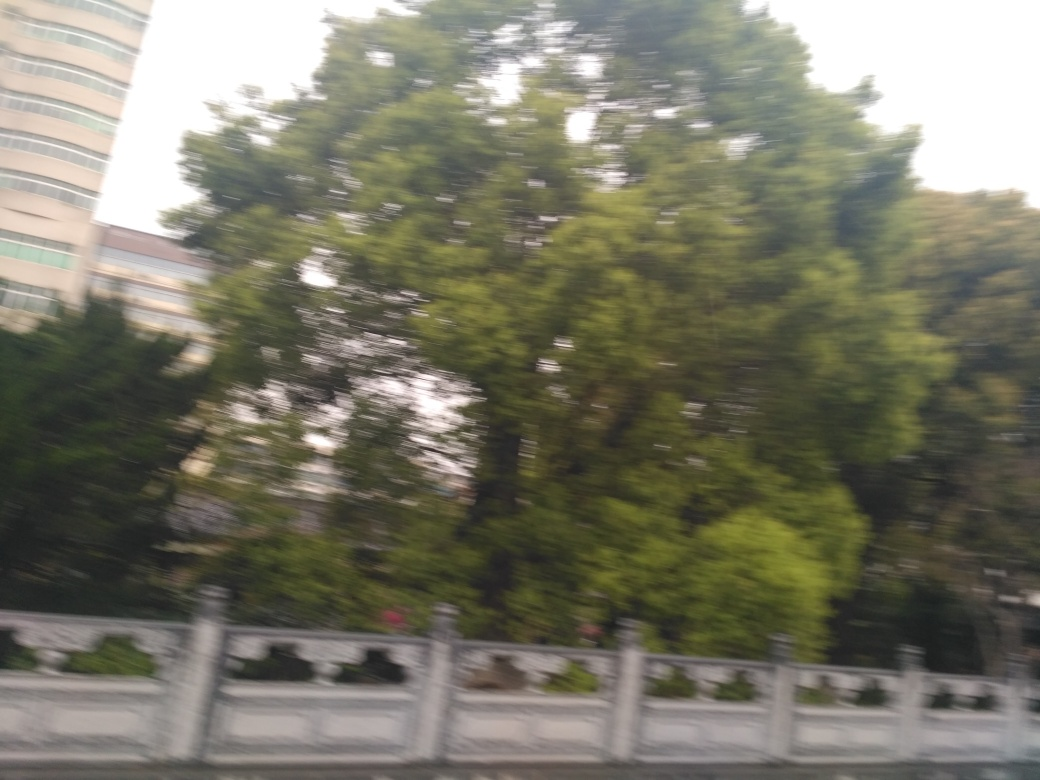What could this image tell us about the location or environment? Given the dense foliage of the trees and the structured design of the guardrail, the image likely depicts a location where careful consideration has been given to combining infrastructure with the surrounding environment. This implies an urban or suburban setting where road safety and greenery are both taken into account, possibly near a park or forested area within a city. 